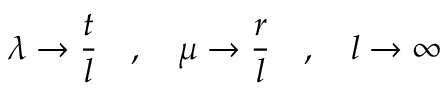<formula> <loc_0><loc_0><loc_500><loc_500>\lambda \to \frac { t } { l } \quad , \quad \mu \to \frac { r } { l } \quad , \quad l \to \infty</formula> 